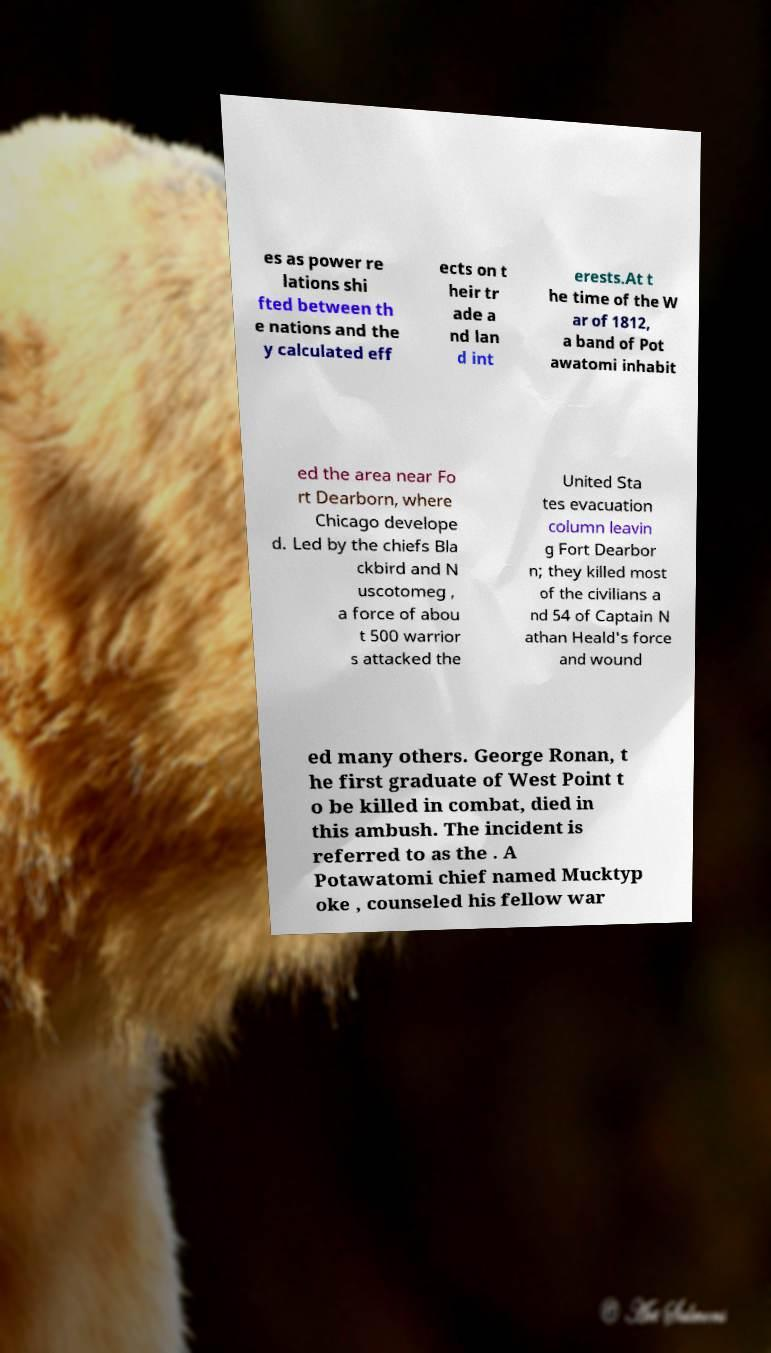Could you extract and type out the text from this image? es as power re lations shi fted between th e nations and the y calculated eff ects on t heir tr ade a nd lan d int erests.At t he time of the W ar of 1812, a band of Pot awatomi inhabit ed the area near Fo rt Dearborn, where Chicago develope d. Led by the chiefs Bla ckbird and N uscotomeg , a force of abou t 500 warrior s attacked the United Sta tes evacuation column leavin g Fort Dearbor n; they killed most of the civilians a nd 54 of Captain N athan Heald's force and wound ed many others. George Ronan, t he first graduate of West Point t o be killed in combat, died in this ambush. The incident is referred to as the . A Potawatomi chief named Mucktyp oke , counseled his fellow war 